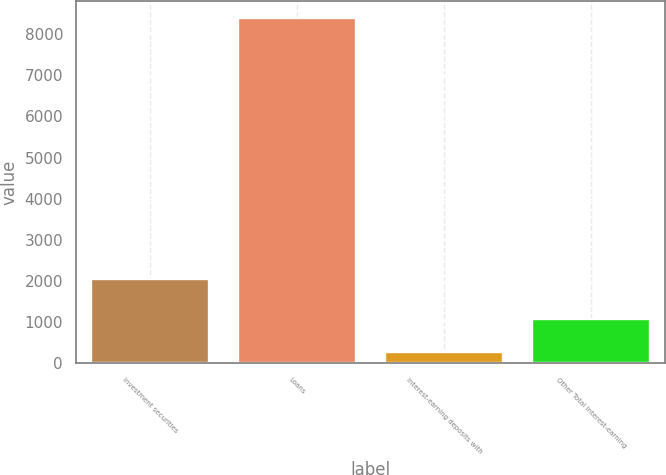Convert chart to OTSL. <chart><loc_0><loc_0><loc_500><loc_500><bar_chart><fcel>Investment securities<fcel>Loans<fcel>Interest-earning deposits with<fcel>Other Total interest-earning<nl><fcel>2059<fcel>8390<fcel>267<fcel>1079.3<nl></chart> 